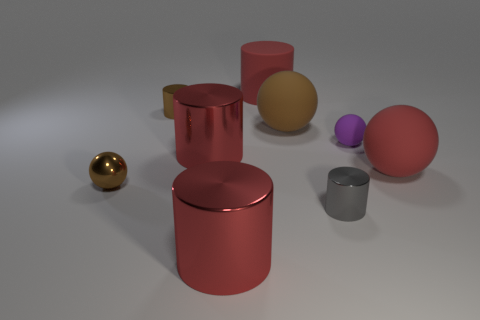Do these objects appear to serve any functional purpose? From this image alone, it's challenging to determine a functional purpose for these objects. They seem to be more representational, possibly made for a display or as models to exhibit different geometric shapes and colors. 